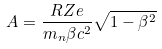Convert formula to latex. <formula><loc_0><loc_0><loc_500><loc_500>A = \frac { R Z e } { m _ { n } \beta c ^ { 2 } } \sqrt { 1 - \beta ^ { 2 } }</formula> 